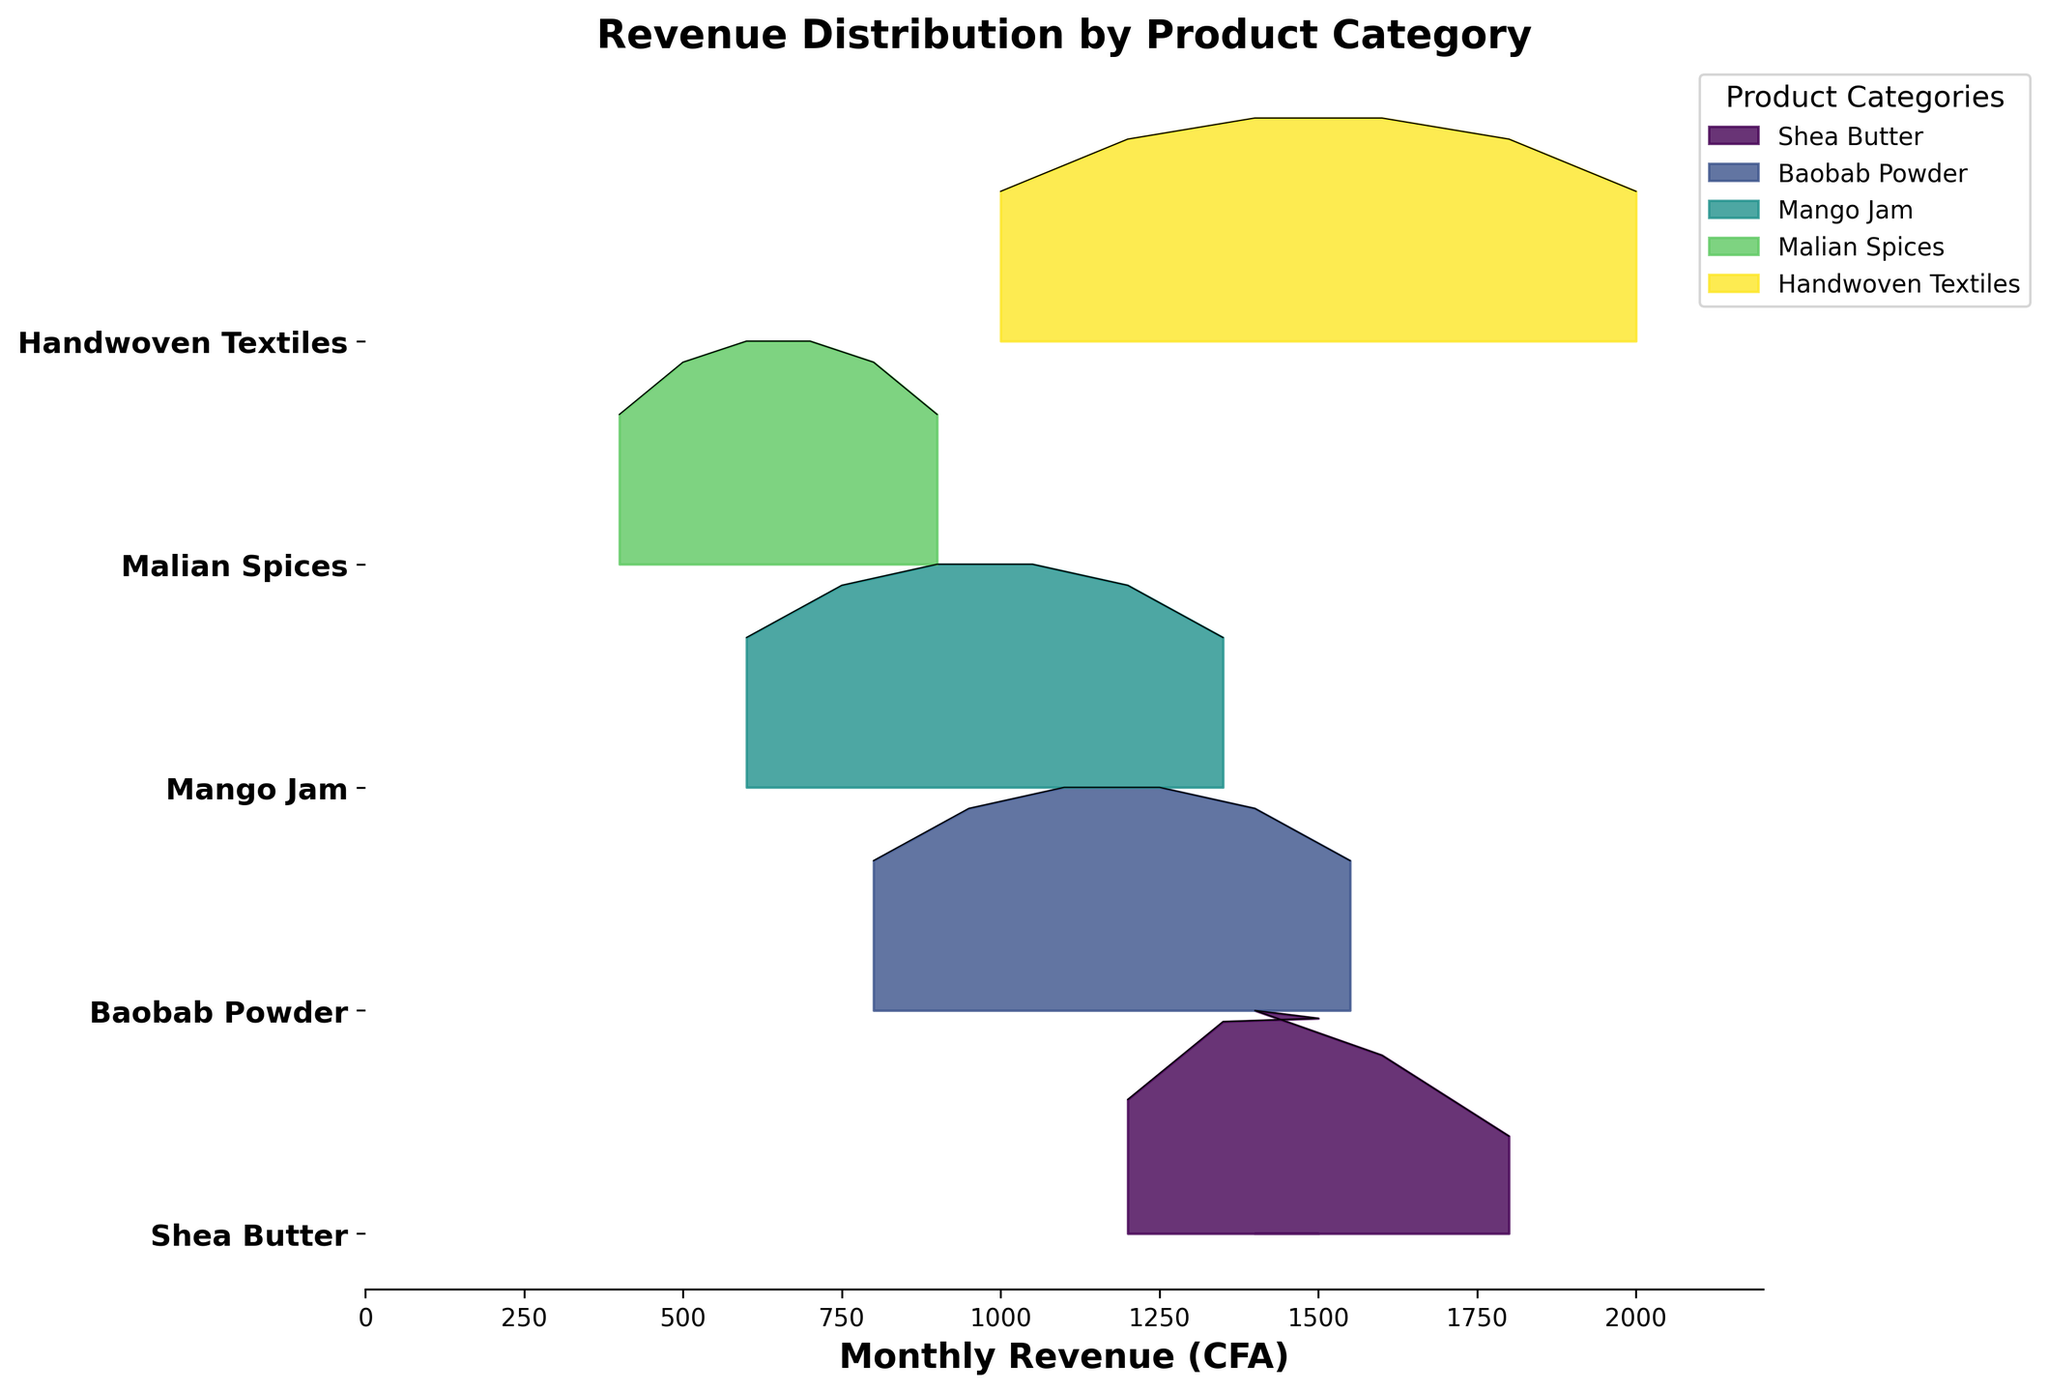what is the title of the plot? The title of the plot is displayed at the top center of the figure. It provides a summary of what the plot represents. The title is "Revenue Distribution by Product Category".
Answer: Revenue Distribution by Product Category How many product categories are represented in the plot? The number of product categories can be counted from the unique labels on the y-axis of the figure. The plot displays 5 different categories: Shea Butter, Baobab Powder, Mango Jam, Malian Spices, and Handwoven Textiles.
Answer: 5 Which product category shows the highest revenue distribution in June? Observing the ridgeline plot, the peak or highest distribution in June can be seen for the category Handwoven Textiles, which has the highest values on the x-axis in June.
Answer: Handwoven Textiles What is the approximate revenue range for Baobab Powder? The ridgeline for Baobab Powder extends horizontally from the lowest to the highest values on the x-axis for this category. The approximate revenue range is from 800 to 1550 CFA.
Answer: 800 to 1550 CFA Which product category appears to have the most consistent revenue distribution over the months? Consistent revenue distribution means fewer fluctuations over different months. Observing the ridgelines, Mango Jam shows a steady increase without significant fluctuations, indicating a consistent distribution.
Answer: Mango Jam Which product category had the lowest revenue in January? Observing the ridgeline plot for January, Malian Spices shows the lowest revenue values on the x-axis.
Answer: Malian Spices Compare the revenue distributions of Mango Jam and Malian Spices. Which has the greater variation? By comparing the spread of the ridgelines of Mango Jam and Malian Spices: Mango Jam shows a wider spread and larger variation in its distribution compared to the more narrowly distributed Malian Spices.
Answer: Mango Jam In which month does Shea Butter achieve its peak revenue? Observing the ridgeline for Shea Butter, its peak or highest distribution value occurs in June.
Answer: June Between Shea Butter and Handwoven Textiles, which category shows a higher revenue in April? Observing the ridgelines for April, Handwoven Textiles has a higher revenue distribution compared to Shea Butter.
Answer: Handwoven Textiles 